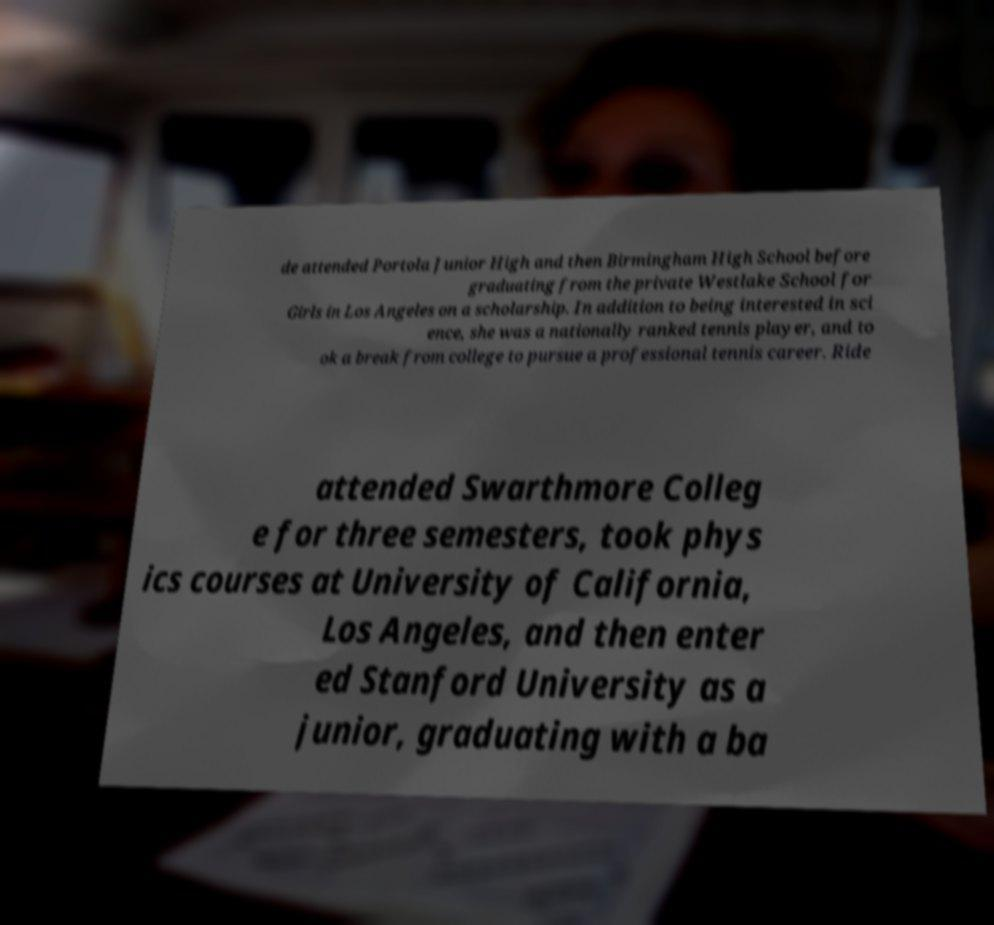For documentation purposes, I need the text within this image transcribed. Could you provide that? de attended Portola Junior High and then Birmingham High School before graduating from the private Westlake School for Girls in Los Angeles on a scholarship. In addition to being interested in sci ence, she was a nationally ranked tennis player, and to ok a break from college to pursue a professional tennis career. Ride attended Swarthmore Colleg e for three semesters, took phys ics courses at University of California, Los Angeles, and then enter ed Stanford University as a junior, graduating with a ba 